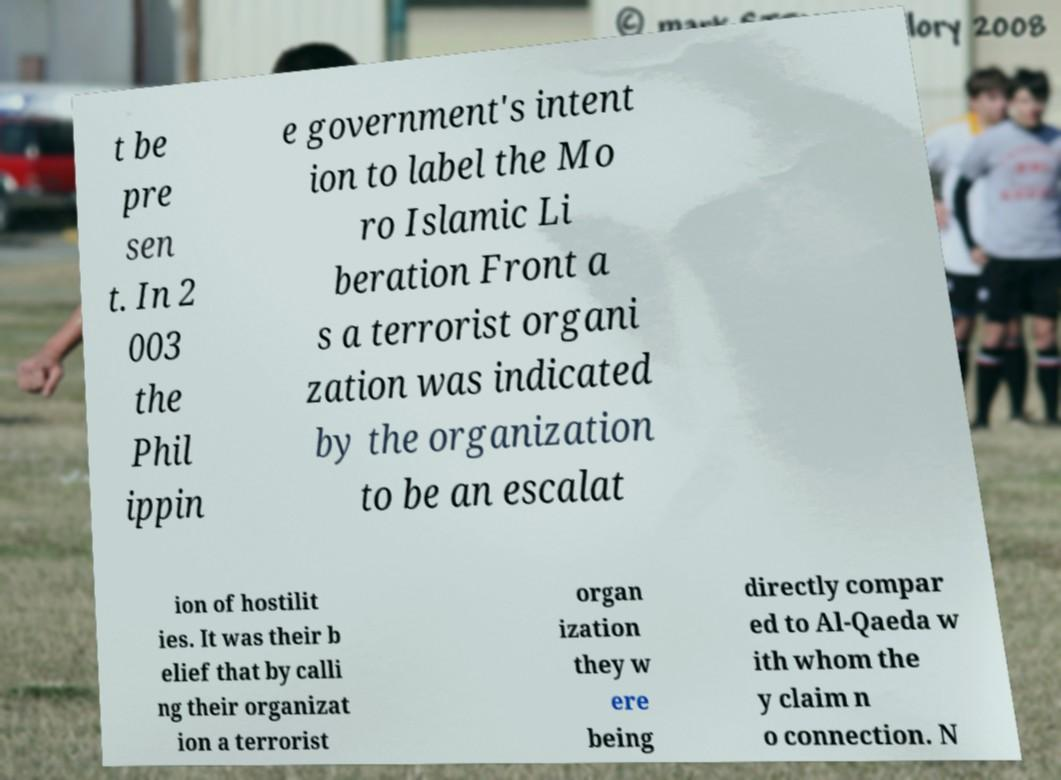Can you read and provide the text displayed in the image?This photo seems to have some interesting text. Can you extract and type it out for me? t be pre sen t. In 2 003 the Phil ippin e government's intent ion to label the Mo ro Islamic Li beration Front a s a terrorist organi zation was indicated by the organization to be an escalat ion of hostilit ies. It was their b elief that by calli ng their organizat ion a terrorist organ ization they w ere being directly compar ed to Al-Qaeda w ith whom the y claim n o connection. N 